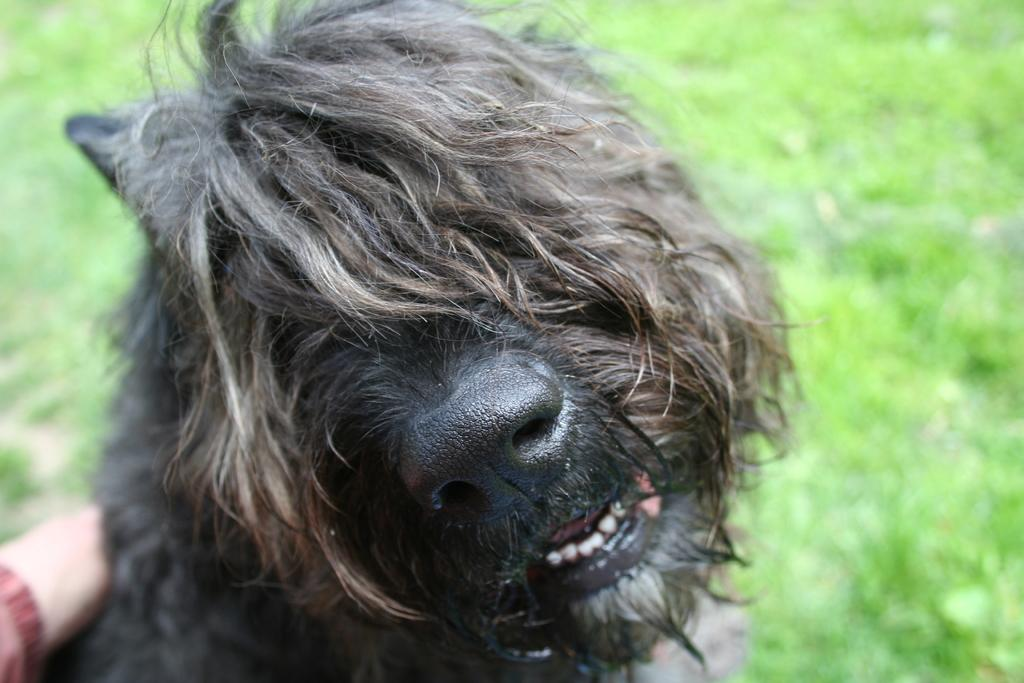What type of animal is in the image? The type of animal cannot be determined from the provided facts. What can be seen in the background of the image? There is ground visible in the background of the image. Whose hand is present in the image? The facts do not specify whose hand is present in the image. How does the image support the acoustics of the room? The image does not support the acoustics of the room, as it is a static image and not a physical object that can affect sound. 